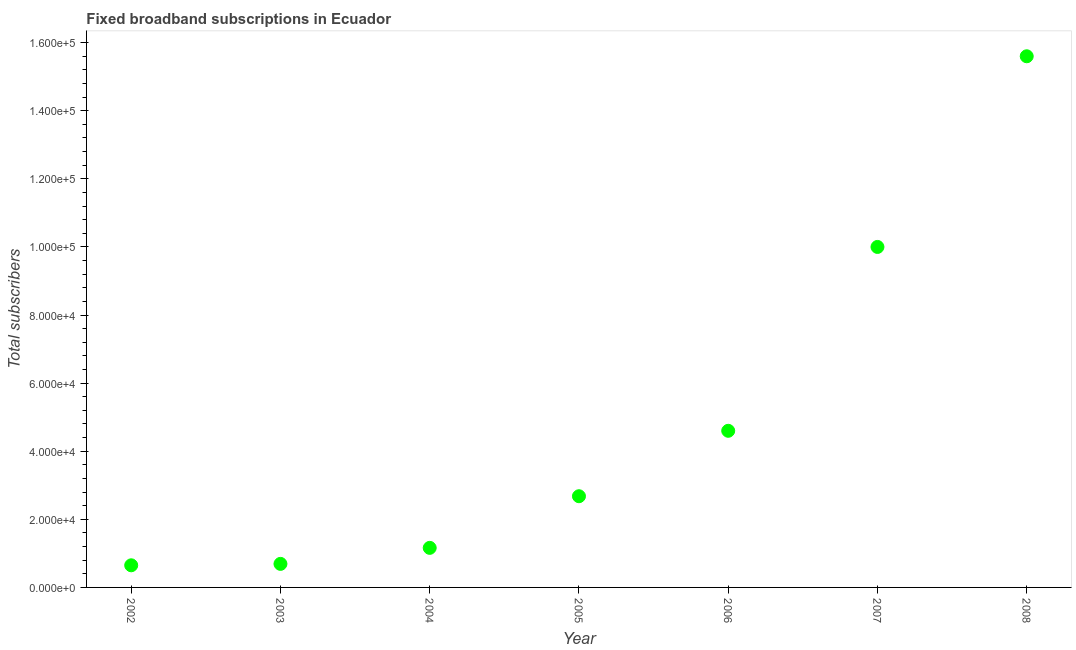What is the total number of fixed broadband subscriptions in 2003?
Ensure brevity in your answer.  6916. Across all years, what is the maximum total number of fixed broadband subscriptions?
Make the answer very short. 1.56e+05. Across all years, what is the minimum total number of fixed broadband subscriptions?
Give a very brief answer. 6499. In which year was the total number of fixed broadband subscriptions maximum?
Give a very brief answer. 2008. What is the sum of the total number of fixed broadband subscriptions?
Keep it short and to the point. 3.54e+05. What is the difference between the total number of fixed broadband subscriptions in 2003 and 2007?
Ensure brevity in your answer.  -9.31e+04. What is the average total number of fixed broadband subscriptions per year?
Your answer should be compact. 5.05e+04. What is the median total number of fixed broadband subscriptions?
Provide a succinct answer. 2.68e+04. In how many years, is the total number of fixed broadband subscriptions greater than 72000 ?
Provide a short and direct response. 2. What is the ratio of the total number of fixed broadband subscriptions in 2003 to that in 2006?
Offer a very short reply. 0.15. What is the difference between the highest and the second highest total number of fixed broadband subscriptions?
Your response must be concise. 5.60e+04. Is the sum of the total number of fixed broadband subscriptions in 2005 and 2007 greater than the maximum total number of fixed broadband subscriptions across all years?
Make the answer very short. No. What is the difference between the highest and the lowest total number of fixed broadband subscriptions?
Provide a short and direct response. 1.49e+05. How many years are there in the graph?
Your answer should be compact. 7. Are the values on the major ticks of Y-axis written in scientific E-notation?
Your answer should be very brief. Yes. What is the title of the graph?
Your answer should be compact. Fixed broadband subscriptions in Ecuador. What is the label or title of the Y-axis?
Your answer should be very brief. Total subscribers. What is the Total subscribers in 2002?
Keep it short and to the point. 6499. What is the Total subscribers in 2003?
Provide a short and direct response. 6916. What is the Total subscribers in 2004?
Offer a very short reply. 1.16e+04. What is the Total subscribers in 2005?
Your answer should be compact. 2.68e+04. What is the Total subscribers in 2006?
Your answer should be compact. 4.60e+04. What is the Total subscribers in 2007?
Give a very brief answer. 1.00e+05. What is the Total subscribers in 2008?
Provide a short and direct response. 1.56e+05. What is the difference between the Total subscribers in 2002 and 2003?
Provide a succinct answer. -417. What is the difference between the Total subscribers in 2002 and 2004?
Provide a short and direct response. -5121. What is the difference between the Total subscribers in 2002 and 2005?
Offer a terse response. -2.03e+04. What is the difference between the Total subscribers in 2002 and 2006?
Your answer should be compact. -3.95e+04. What is the difference between the Total subscribers in 2002 and 2007?
Ensure brevity in your answer.  -9.35e+04. What is the difference between the Total subscribers in 2002 and 2008?
Make the answer very short. -1.49e+05. What is the difference between the Total subscribers in 2003 and 2004?
Your response must be concise. -4704. What is the difference between the Total subscribers in 2003 and 2005?
Make the answer very short. -1.99e+04. What is the difference between the Total subscribers in 2003 and 2006?
Your answer should be very brief. -3.91e+04. What is the difference between the Total subscribers in 2003 and 2007?
Offer a very short reply. -9.31e+04. What is the difference between the Total subscribers in 2003 and 2008?
Keep it short and to the point. -1.49e+05. What is the difference between the Total subscribers in 2004 and 2005?
Give a very brief answer. -1.52e+04. What is the difference between the Total subscribers in 2004 and 2006?
Provide a short and direct response. -3.44e+04. What is the difference between the Total subscribers in 2004 and 2007?
Your answer should be compact. -8.84e+04. What is the difference between the Total subscribers in 2004 and 2008?
Offer a terse response. -1.44e+05. What is the difference between the Total subscribers in 2005 and 2006?
Ensure brevity in your answer.  -1.92e+04. What is the difference between the Total subscribers in 2005 and 2007?
Make the answer very short. -7.32e+04. What is the difference between the Total subscribers in 2005 and 2008?
Give a very brief answer. -1.29e+05. What is the difference between the Total subscribers in 2006 and 2007?
Your answer should be very brief. -5.40e+04. What is the difference between the Total subscribers in 2006 and 2008?
Make the answer very short. -1.10e+05. What is the difference between the Total subscribers in 2007 and 2008?
Ensure brevity in your answer.  -5.60e+04. What is the ratio of the Total subscribers in 2002 to that in 2003?
Ensure brevity in your answer.  0.94. What is the ratio of the Total subscribers in 2002 to that in 2004?
Provide a short and direct response. 0.56. What is the ratio of the Total subscribers in 2002 to that in 2005?
Make the answer very short. 0.24. What is the ratio of the Total subscribers in 2002 to that in 2006?
Provide a short and direct response. 0.14. What is the ratio of the Total subscribers in 2002 to that in 2007?
Offer a very short reply. 0.07. What is the ratio of the Total subscribers in 2002 to that in 2008?
Provide a succinct answer. 0.04. What is the ratio of the Total subscribers in 2003 to that in 2004?
Your answer should be very brief. 0.59. What is the ratio of the Total subscribers in 2003 to that in 2005?
Ensure brevity in your answer.  0.26. What is the ratio of the Total subscribers in 2003 to that in 2006?
Your answer should be very brief. 0.15. What is the ratio of the Total subscribers in 2003 to that in 2007?
Your answer should be very brief. 0.07. What is the ratio of the Total subscribers in 2003 to that in 2008?
Provide a short and direct response. 0.04. What is the ratio of the Total subscribers in 2004 to that in 2005?
Your answer should be compact. 0.43. What is the ratio of the Total subscribers in 2004 to that in 2006?
Provide a short and direct response. 0.25. What is the ratio of the Total subscribers in 2004 to that in 2007?
Offer a very short reply. 0.12. What is the ratio of the Total subscribers in 2004 to that in 2008?
Ensure brevity in your answer.  0.07. What is the ratio of the Total subscribers in 2005 to that in 2006?
Ensure brevity in your answer.  0.58. What is the ratio of the Total subscribers in 2005 to that in 2007?
Your answer should be compact. 0.27. What is the ratio of the Total subscribers in 2005 to that in 2008?
Your response must be concise. 0.17. What is the ratio of the Total subscribers in 2006 to that in 2007?
Your response must be concise. 0.46. What is the ratio of the Total subscribers in 2006 to that in 2008?
Keep it short and to the point. 0.29. What is the ratio of the Total subscribers in 2007 to that in 2008?
Make the answer very short. 0.64. 